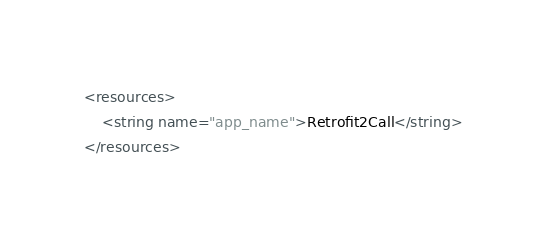<code> <loc_0><loc_0><loc_500><loc_500><_XML_><resources>
    <string name="app_name">Retrofit2Call</string>
</resources>
</code> 